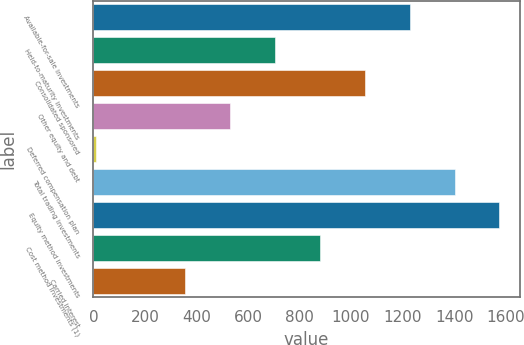Convert chart to OTSL. <chart><loc_0><loc_0><loc_500><loc_500><bar_chart><fcel>Available-for-sale investments<fcel>Held-to-maturity investments<fcel>Consolidated sponsored<fcel>Other equity and debt<fcel>Deferred compensation plan<fcel>Total trading investments<fcel>Equity method investments<fcel>Cost method investments (1)<fcel>Carried interest<nl><fcel>1227.7<fcel>705.4<fcel>1053.6<fcel>531.3<fcel>9<fcel>1401.8<fcel>1575.9<fcel>879.5<fcel>357.2<nl></chart> 